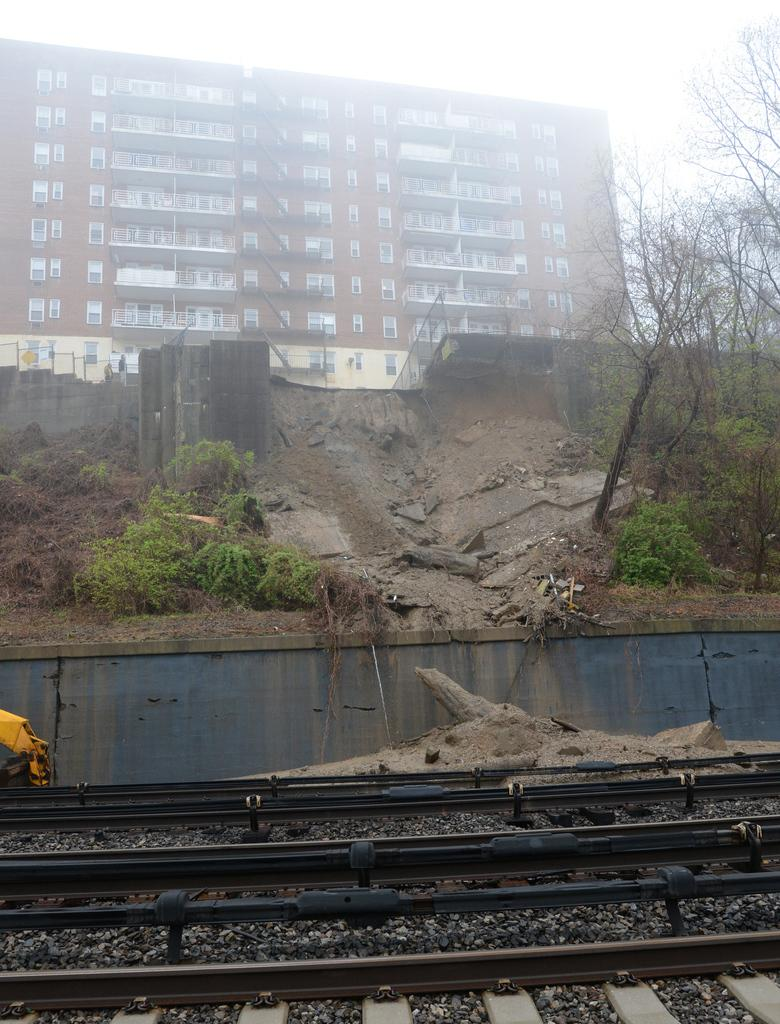What is on the ground in the image? There are railway tracks on the ground in the image. What type of vegetation can be seen in the image? There are plants and trees in the image. What is visible in the background of the image? There is a building in the background of the image. What is the condition of the sky in the image? The sky is clear and clear in the image. How many women are sitting on the railway tracks in the image? There are no women present in the image, and the railway tracks are not being used for seating. 